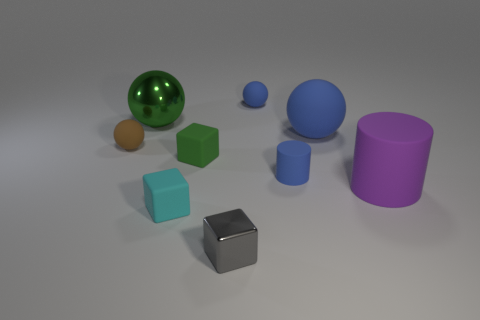Subtract all tiny blue rubber spheres. How many spheres are left? 3 Subtract all purple cylinders. How many blue balls are left? 2 Subtract 1 spheres. How many spheres are left? 3 Subtract all brown balls. How many balls are left? 3 Add 1 purple objects. How many objects exist? 10 Subtract all cylinders. How many objects are left? 7 Subtract all purple balls. Subtract all yellow blocks. How many balls are left? 4 Add 8 small brown metal cylinders. How many small brown metal cylinders exist? 8 Subtract 1 green cubes. How many objects are left? 8 Subtract all purple cylinders. Subtract all cubes. How many objects are left? 5 